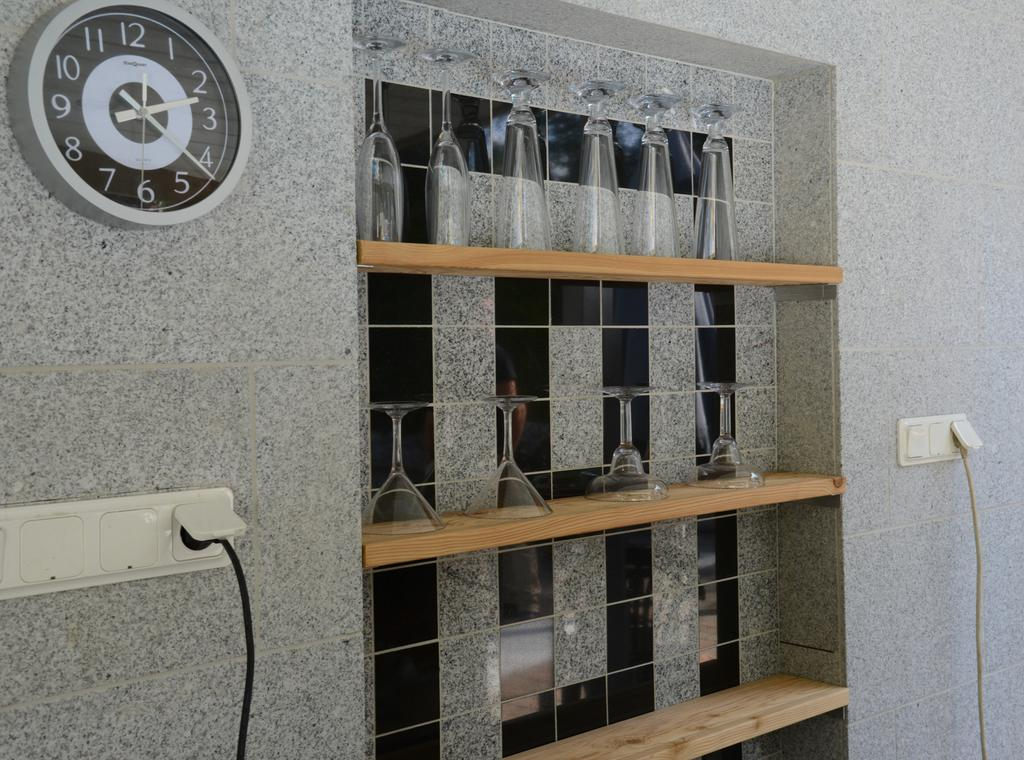<image>
Offer a succinct explanation of the picture presented. A clock pointing to the numbers 2 and 4 sits on a wall next to several glasses 